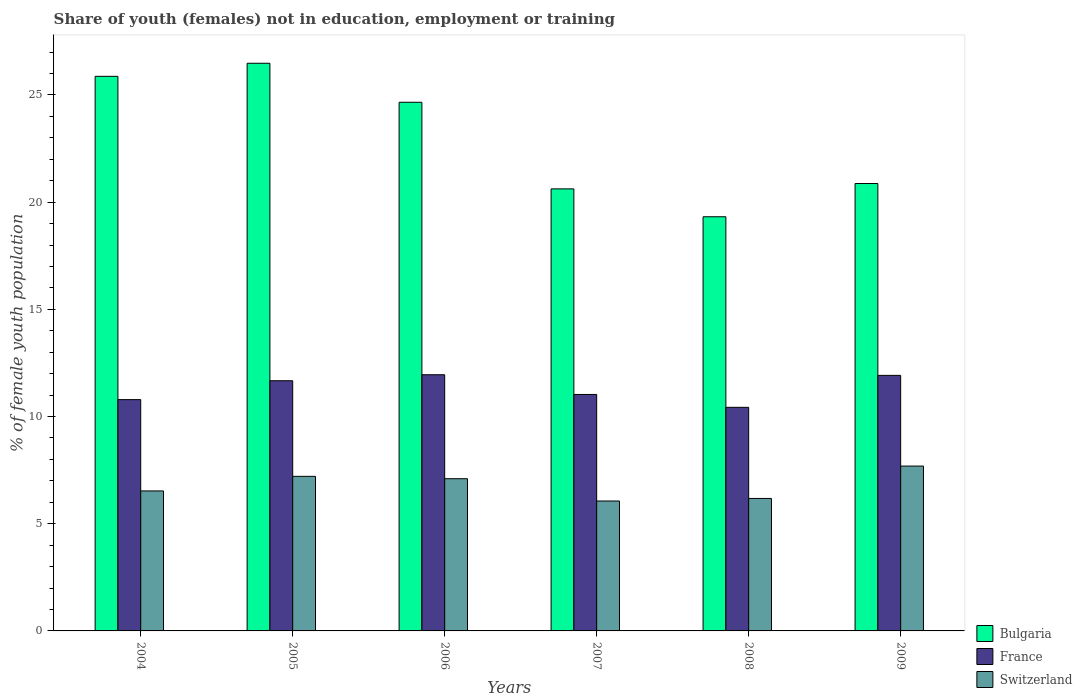How many groups of bars are there?
Make the answer very short. 6. Are the number of bars per tick equal to the number of legend labels?
Your answer should be very brief. Yes. Are the number of bars on each tick of the X-axis equal?
Provide a succinct answer. Yes. How many bars are there on the 3rd tick from the right?
Your answer should be very brief. 3. What is the percentage of unemployed female population in in Switzerland in 2006?
Provide a succinct answer. 7.1. Across all years, what is the maximum percentage of unemployed female population in in Switzerland?
Make the answer very short. 7.69. Across all years, what is the minimum percentage of unemployed female population in in Switzerland?
Provide a short and direct response. 6.06. What is the total percentage of unemployed female population in in Bulgaria in the graph?
Keep it short and to the point. 137.82. What is the difference between the percentage of unemployed female population in in Switzerland in 2006 and that in 2008?
Make the answer very short. 0.92. What is the difference between the percentage of unemployed female population in in France in 2005 and the percentage of unemployed female population in in Switzerland in 2009?
Provide a short and direct response. 3.98. What is the average percentage of unemployed female population in in Switzerland per year?
Provide a short and direct response. 6.79. In the year 2007, what is the difference between the percentage of unemployed female population in in France and percentage of unemployed female population in in Bulgaria?
Give a very brief answer. -9.59. What is the ratio of the percentage of unemployed female population in in Bulgaria in 2006 to that in 2008?
Make the answer very short. 1.28. Is the percentage of unemployed female population in in France in 2005 less than that in 2009?
Your answer should be very brief. Yes. What is the difference between the highest and the second highest percentage of unemployed female population in in Switzerland?
Ensure brevity in your answer.  0.48. What is the difference between the highest and the lowest percentage of unemployed female population in in France?
Your answer should be compact. 1.52. In how many years, is the percentage of unemployed female population in in Switzerland greater than the average percentage of unemployed female population in in Switzerland taken over all years?
Provide a succinct answer. 3. Is it the case that in every year, the sum of the percentage of unemployed female population in in France and percentage of unemployed female population in in Bulgaria is greater than the percentage of unemployed female population in in Switzerland?
Your answer should be very brief. Yes. Are the values on the major ticks of Y-axis written in scientific E-notation?
Keep it short and to the point. No. Does the graph contain any zero values?
Offer a terse response. No. How many legend labels are there?
Provide a short and direct response. 3. How are the legend labels stacked?
Provide a succinct answer. Vertical. What is the title of the graph?
Keep it short and to the point. Share of youth (females) not in education, employment or training. What is the label or title of the Y-axis?
Give a very brief answer. % of female youth population. What is the % of female youth population of Bulgaria in 2004?
Give a very brief answer. 25.87. What is the % of female youth population of France in 2004?
Keep it short and to the point. 10.79. What is the % of female youth population in Switzerland in 2004?
Make the answer very short. 6.53. What is the % of female youth population of Bulgaria in 2005?
Make the answer very short. 26.48. What is the % of female youth population in France in 2005?
Keep it short and to the point. 11.67. What is the % of female youth population in Switzerland in 2005?
Make the answer very short. 7.21. What is the % of female youth population of Bulgaria in 2006?
Provide a succinct answer. 24.66. What is the % of female youth population in France in 2006?
Keep it short and to the point. 11.95. What is the % of female youth population in Switzerland in 2006?
Your answer should be very brief. 7.1. What is the % of female youth population in Bulgaria in 2007?
Your answer should be very brief. 20.62. What is the % of female youth population of France in 2007?
Offer a very short reply. 11.03. What is the % of female youth population in Switzerland in 2007?
Provide a short and direct response. 6.06. What is the % of female youth population in Bulgaria in 2008?
Provide a short and direct response. 19.32. What is the % of female youth population of France in 2008?
Your response must be concise. 10.43. What is the % of female youth population of Switzerland in 2008?
Make the answer very short. 6.18. What is the % of female youth population in Bulgaria in 2009?
Offer a very short reply. 20.87. What is the % of female youth population of France in 2009?
Your response must be concise. 11.92. What is the % of female youth population in Switzerland in 2009?
Your answer should be very brief. 7.69. Across all years, what is the maximum % of female youth population in Bulgaria?
Your answer should be compact. 26.48. Across all years, what is the maximum % of female youth population of France?
Your response must be concise. 11.95. Across all years, what is the maximum % of female youth population of Switzerland?
Your answer should be compact. 7.69. Across all years, what is the minimum % of female youth population in Bulgaria?
Make the answer very short. 19.32. Across all years, what is the minimum % of female youth population in France?
Offer a very short reply. 10.43. Across all years, what is the minimum % of female youth population of Switzerland?
Your answer should be compact. 6.06. What is the total % of female youth population in Bulgaria in the graph?
Provide a succinct answer. 137.82. What is the total % of female youth population in France in the graph?
Offer a very short reply. 67.79. What is the total % of female youth population in Switzerland in the graph?
Provide a succinct answer. 40.77. What is the difference between the % of female youth population in Bulgaria in 2004 and that in 2005?
Offer a terse response. -0.61. What is the difference between the % of female youth population in France in 2004 and that in 2005?
Offer a very short reply. -0.88. What is the difference between the % of female youth population of Switzerland in 2004 and that in 2005?
Make the answer very short. -0.68. What is the difference between the % of female youth population of Bulgaria in 2004 and that in 2006?
Provide a succinct answer. 1.21. What is the difference between the % of female youth population in France in 2004 and that in 2006?
Provide a short and direct response. -1.16. What is the difference between the % of female youth population in Switzerland in 2004 and that in 2006?
Offer a terse response. -0.57. What is the difference between the % of female youth population in Bulgaria in 2004 and that in 2007?
Your answer should be compact. 5.25. What is the difference between the % of female youth population of France in 2004 and that in 2007?
Provide a succinct answer. -0.24. What is the difference between the % of female youth population of Switzerland in 2004 and that in 2007?
Keep it short and to the point. 0.47. What is the difference between the % of female youth population in Bulgaria in 2004 and that in 2008?
Offer a terse response. 6.55. What is the difference between the % of female youth population of France in 2004 and that in 2008?
Give a very brief answer. 0.36. What is the difference between the % of female youth population in Bulgaria in 2004 and that in 2009?
Your answer should be compact. 5. What is the difference between the % of female youth population of France in 2004 and that in 2009?
Keep it short and to the point. -1.13. What is the difference between the % of female youth population of Switzerland in 2004 and that in 2009?
Your response must be concise. -1.16. What is the difference between the % of female youth population of Bulgaria in 2005 and that in 2006?
Provide a succinct answer. 1.82. What is the difference between the % of female youth population in France in 2005 and that in 2006?
Offer a very short reply. -0.28. What is the difference between the % of female youth population in Switzerland in 2005 and that in 2006?
Offer a very short reply. 0.11. What is the difference between the % of female youth population in Bulgaria in 2005 and that in 2007?
Provide a short and direct response. 5.86. What is the difference between the % of female youth population of France in 2005 and that in 2007?
Ensure brevity in your answer.  0.64. What is the difference between the % of female youth population in Switzerland in 2005 and that in 2007?
Your answer should be compact. 1.15. What is the difference between the % of female youth population of Bulgaria in 2005 and that in 2008?
Your response must be concise. 7.16. What is the difference between the % of female youth population in France in 2005 and that in 2008?
Offer a terse response. 1.24. What is the difference between the % of female youth population in Switzerland in 2005 and that in 2008?
Keep it short and to the point. 1.03. What is the difference between the % of female youth population in Bulgaria in 2005 and that in 2009?
Your response must be concise. 5.61. What is the difference between the % of female youth population of Switzerland in 2005 and that in 2009?
Provide a short and direct response. -0.48. What is the difference between the % of female youth population in Bulgaria in 2006 and that in 2007?
Provide a succinct answer. 4.04. What is the difference between the % of female youth population in Switzerland in 2006 and that in 2007?
Keep it short and to the point. 1.04. What is the difference between the % of female youth population in Bulgaria in 2006 and that in 2008?
Offer a terse response. 5.34. What is the difference between the % of female youth population of France in 2006 and that in 2008?
Offer a very short reply. 1.52. What is the difference between the % of female youth population in Bulgaria in 2006 and that in 2009?
Your answer should be compact. 3.79. What is the difference between the % of female youth population in France in 2006 and that in 2009?
Provide a succinct answer. 0.03. What is the difference between the % of female youth population in Switzerland in 2006 and that in 2009?
Your answer should be very brief. -0.59. What is the difference between the % of female youth population of France in 2007 and that in 2008?
Offer a very short reply. 0.6. What is the difference between the % of female youth population in Switzerland in 2007 and that in 2008?
Make the answer very short. -0.12. What is the difference between the % of female youth population of Bulgaria in 2007 and that in 2009?
Give a very brief answer. -0.25. What is the difference between the % of female youth population in France in 2007 and that in 2009?
Provide a short and direct response. -0.89. What is the difference between the % of female youth population in Switzerland in 2007 and that in 2009?
Provide a succinct answer. -1.63. What is the difference between the % of female youth population in Bulgaria in 2008 and that in 2009?
Your response must be concise. -1.55. What is the difference between the % of female youth population in France in 2008 and that in 2009?
Make the answer very short. -1.49. What is the difference between the % of female youth population in Switzerland in 2008 and that in 2009?
Provide a succinct answer. -1.51. What is the difference between the % of female youth population of Bulgaria in 2004 and the % of female youth population of Switzerland in 2005?
Provide a succinct answer. 18.66. What is the difference between the % of female youth population of France in 2004 and the % of female youth population of Switzerland in 2005?
Give a very brief answer. 3.58. What is the difference between the % of female youth population of Bulgaria in 2004 and the % of female youth population of France in 2006?
Your answer should be very brief. 13.92. What is the difference between the % of female youth population of Bulgaria in 2004 and the % of female youth population of Switzerland in 2006?
Offer a terse response. 18.77. What is the difference between the % of female youth population of France in 2004 and the % of female youth population of Switzerland in 2006?
Give a very brief answer. 3.69. What is the difference between the % of female youth population in Bulgaria in 2004 and the % of female youth population in France in 2007?
Keep it short and to the point. 14.84. What is the difference between the % of female youth population in Bulgaria in 2004 and the % of female youth population in Switzerland in 2007?
Make the answer very short. 19.81. What is the difference between the % of female youth population of France in 2004 and the % of female youth population of Switzerland in 2007?
Your answer should be very brief. 4.73. What is the difference between the % of female youth population of Bulgaria in 2004 and the % of female youth population of France in 2008?
Ensure brevity in your answer.  15.44. What is the difference between the % of female youth population of Bulgaria in 2004 and the % of female youth population of Switzerland in 2008?
Provide a short and direct response. 19.69. What is the difference between the % of female youth population in France in 2004 and the % of female youth population in Switzerland in 2008?
Make the answer very short. 4.61. What is the difference between the % of female youth population in Bulgaria in 2004 and the % of female youth population in France in 2009?
Your answer should be compact. 13.95. What is the difference between the % of female youth population of Bulgaria in 2004 and the % of female youth population of Switzerland in 2009?
Give a very brief answer. 18.18. What is the difference between the % of female youth population of France in 2004 and the % of female youth population of Switzerland in 2009?
Ensure brevity in your answer.  3.1. What is the difference between the % of female youth population in Bulgaria in 2005 and the % of female youth population in France in 2006?
Make the answer very short. 14.53. What is the difference between the % of female youth population in Bulgaria in 2005 and the % of female youth population in Switzerland in 2006?
Keep it short and to the point. 19.38. What is the difference between the % of female youth population in France in 2005 and the % of female youth population in Switzerland in 2006?
Your response must be concise. 4.57. What is the difference between the % of female youth population of Bulgaria in 2005 and the % of female youth population of France in 2007?
Offer a very short reply. 15.45. What is the difference between the % of female youth population in Bulgaria in 2005 and the % of female youth population in Switzerland in 2007?
Provide a short and direct response. 20.42. What is the difference between the % of female youth population of France in 2005 and the % of female youth population of Switzerland in 2007?
Offer a terse response. 5.61. What is the difference between the % of female youth population in Bulgaria in 2005 and the % of female youth population in France in 2008?
Provide a short and direct response. 16.05. What is the difference between the % of female youth population in Bulgaria in 2005 and the % of female youth population in Switzerland in 2008?
Make the answer very short. 20.3. What is the difference between the % of female youth population in France in 2005 and the % of female youth population in Switzerland in 2008?
Your answer should be very brief. 5.49. What is the difference between the % of female youth population of Bulgaria in 2005 and the % of female youth population of France in 2009?
Ensure brevity in your answer.  14.56. What is the difference between the % of female youth population of Bulgaria in 2005 and the % of female youth population of Switzerland in 2009?
Provide a succinct answer. 18.79. What is the difference between the % of female youth population of France in 2005 and the % of female youth population of Switzerland in 2009?
Make the answer very short. 3.98. What is the difference between the % of female youth population of Bulgaria in 2006 and the % of female youth population of France in 2007?
Provide a short and direct response. 13.63. What is the difference between the % of female youth population in France in 2006 and the % of female youth population in Switzerland in 2007?
Your answer should be very brief. 5.89. What is the difference between the % of female youth population in Bulgaria in 2006 and the % of female youth population in France in 2008?
Provide a short and direct response. 14.23. What is the difference between the % of female youth population in Bulgaria in 2006 and the % of female youth population in Switzerland in 2008?
Make the answer very short. 18.48. What is the difference between the % of female youth population of France in 2006 and the % of female youth population of Switzerland in 2008?
Keep it short and to the point. 5.77. What is the difference between the % of female youth population of Bulgaria in 2006 and the % of female youth population of France in 2009?
Offer a very short reply. 12.74. What is the difference between the % of female youth population in Bulgaria in 2006 and the % of female youth population in Switzerland in 2009?
Your answer should be very brief. 16.97. What is the difference between the % of female youth population in France in 2006 and the % of female youth population in Switzerland in 2009?
Give a very brief answer. 4.26. What is the difference between the % of female youth population of Bulgaria in 2007 and the % of female youth population of France in 2008?
Your answer should be very brief. 10.19. What is the difference between the % of female youth population in Bulgaria in 2007 and the % of female youth population in Switzerland in 2008?
Your answer should be compact. 14.44. What is the difference between the % of female youth population in France in 2007 and the % of female youth population in Switzerland in 2008?
Give a very brief answer. 4.85. What is the difference between the % of female youth population in Bulgaria in 2007 and the % of female youth population in Switzerland in 2009?
Provide a succinct answer. 12.93. What is the difference between the % of female youth population in France in 2007 and the % of female youth population in Switzerland in 2009?
Offer a very short reply. 3.34. What is the difference between the % of female youth population of Bulgaria in 2008 and the % of female youth population of Switzerland in 2009?
Your answer should be compact. 11.63. What is the difference between the % of female youth population of France in 2008 and the % of female youth population of Switzerland in 2009?
Offer a very short reply. 2.74. What is the average % of female youth population in Bulgaria per year?
Provide a short and direct response. 22.97. What is the average % of female youth population in France per year?
Provide a succinct answer. 11.3. What is the average % of female youth population in Switzerland per year?
Give a very brief answer. 6.79. In the year 2004, what is the difference between the % of female youth population in Bulgaria and % of female youth population in France?
Keep it short and to the point. 15.08. In the year 2004, what is the difference between the % of female youth population in Bulgaria and % of female youth population in Switzerland?
Your response must be concise. 19.34. In the year 2004, what is the difference between the % of female youth population of France and % of female youth population of Switzerland?
Your answer should be very brief. 4.26. In the year 2005, what is the difference between the % of female youth population of Bulgaria and % of female youth population of France?
Make the answer very short. 14.81. In the year 2005, what is the difference between the % of female youth population of Bulgaria and % of female youth population of Switzerland?
Make the answer very short. 19.27. In the year 2005, what is the difference between the % of female youth population of France and % of female youth population of Switzerland?
Offer a very short reply. 4.46. In the year 2006, what is the difference between the % of female youth population in Bulgaria and % of female youth population in France?
Provide a succinct answer. 12.71. In the year 2006, what is the difference between the % of female youth population of Bulgaria and % of female youth population of Switzerland?
Ensure brevity in your answer.  17.56. In the year 2006, what is the difference between the % of female youth population of France and % of female youth population of Switzerland?
Keep it short and to the point. 4.85. In the year 2007, what is the difference between the % of female youth population of Bulgaria and % of female youth population of France?
Ensure brevity in your answer.  9.59. In the year 2007, what is the difference between the % of female youth population in Bulgaria and % of female youth population in Switzerland?
Offer a terse response. 14.56. In the year 2007, what is the difference between the % of female youth population in France and % of female youth population in Switzerland?
Offer a terse response. 4.97. In the year 2008, what is the difference between the % of female youth population in Bulgaria and % of female youth population in France?
Provide a short and direct response. 8.89. In the year 2008, what is the difference between the % of female youth population in Bulgaria and % of female youth population in Switzerland?
Give a very brief answer. 13.14. In the year 2008, what is the difference between the % of female youth population in France and % of female youth population in Switzerland?
Provide a succinct answer. 4.25. In the year 2009, what is the difference between the % of female youth population of Bulgaria and % of female youth population of France?
Your answer should be compact. 8.95. In the year 2009, what is the difference between the % of female youth population in Bulgaria and % of female youth population in Switzerland?
Keep it short and to the point. 13.18. In the year 2009, what is the difference between the % of female youth population in France and % of female youth population in Switzerland?
Your answer should be very brief. 4.23. What is the ratio of the % of female youth population of France in 2004 to that in 2005?
Your answer should be very brief. 0.92. What is the ratio of the % of female youth population in Switzerland in 2004 to that in 2005?
Your answer should be very brief. 0.91. What is the ratio of the % of female youth population in Bulgaria in 2004 to that in 2006?
Offer a terse response. 1.05. What is the ratio of the % of female youth population of France in 2004 to that in 2006?
Your response must be concise. 0.9. What is the ratio of the % of female youth population in Switzerland in 2004 to that in 2006?
Provide a succinct answer. 0.92. What is the ratio of the % of female youth population in Bulgaria in 2004 to that in 2007?
Offer a terse response. 1.25. What is the ratio of the % of female youth population in France in 2004 to that in 2007?
Ensure brevity in your answer.  0.98. What is the ratio of the % of female youth population in Switzerland in 2004 to that in 2007?
Your answer should be compact. 1.08. What is the ratio of the % of female youth population of Bulgaria in 2004 to that in 2008?
Your answer should be compact. 1.34. What is the ratio of the % of female youth population of France in 2004 to that in 2008?
Give a very brief answer. 1.03. What is the ratio of the % of female youth population of Switzerland in 2004 to that in 2008?
Provide a short and direct response. 1.06. What is the ratio of the % of female youth population of Bulgaria in 2004 to that in 2009?
Your answer should be very brief. 1.24. What is the ratio of the % of female youth population in France in 2004 to that in 2009?
Your answer should be very brief. 0.91. What is the ratio of the % of female youth population of Switzerland in 2004 to that in 2009?
Provide a succinct answer. 0.85. What is the ratio of the % of female youth population of Bulgaria in 2005 to that in 2006?
Ensure brevity in your answer.  1.07. What is the ratio of the % of female youth population in France in 2005 to that in 2006?
Offer a terse response. 0.98. What is the ratio of the % of female youth population of Switzerland in 2005 to that in 2006?
Offer a very short reply. 1.02. What is the ratio of the % of female youth population in Bulgaria in 2005 to that in 2007?
Your response must be concise. 1.28. What is the ratio of the % of female youth population in France in 2005 to that in 2007?
Keep it short and to the point. 1.06. What is the ratio of the % of female youth population in Switzerland in 2005 to that in 2007?
Your answer should be compact. 1.19. What is the ratio of the % of female youth population in Bulgaria in 2005 to that in 2008?
Make the answer very short. 1.37. What is the ratio of the % of female youth population in France in 2005 to that in 2008?
Ensure brevity in your answer.  1.12. What is the ratio of the % of female youth population of Switzerland in 2005 to that in 2008?
Offer a very short reply. 1.17. What is the ratio of the % of female youth population in Bulgaria in 2005 to that in 2009?
Your answer should be very brief. 1.27. What is the ratio of the % of female youth population in France in 2005 to that in 2009?
Ensure brevity in your answer.  0.98. What is the ratio of the % of female youth population of Switzerland in 2005 to that in 2009?
Ensure brevity in your answer.  0.94. What is the ratio of the % of female youth population of Bulgaria in 2006 to that in 2007?
Make the answer very short. 1.2. What is the ratio of the % of female youth population of France in 2006 to that in 2007?
Give a very brief answer. 1.08. What is the ratio of the % of female youth population in Switzerland in 2006 to that in 2007?
Make the answer very short. 1.17. What is the ratio of the % of female youth population in Bulgaria in 2006 to that in 2008?
Make the answer very short. 1.28. What is the ratio of the % of female youth population in France in 2006 to that in 2008?
Offer a terse response. 1.15. What is the ratio of the % of female youth population of Switzerland in 2006 to that in 2008?
Provide a succinct answer. 1.15. What is the ratio of the % of female youth population of Bulgaria in 2006 to that in 2009?
Offer a very short reply. 1.18. What is the ratio of the % of female youth population of Switzerland in 2006 to that in 2009?
Offer a terse response. 0.92. What is the ratio of the % of female youth population of Bulgaria in 2007 to that in 2008?
Offer a terse response. 1.07. What is the ratio of the % of female youth population in France in 2007 to that in 2008?
Make the answer very short. 1.06. What is the ratio of the % of female youth population of Switzerland in 2007 to that in 2008?
Keep it short and to the point. 0.98. What is the ratio of the % of female youth population in Bulgaria in 2007 to that in 2009?
Provide a succinct answer. 0.99. What is the ratio of the % of female youth population of France in 2007 to that in 2009?
Provide a succinct answer. 0.93. What is the ratio of the % of female youth population of Switzerland in 2007 to that in 2009?
Your response must be concise. 0.79. What is the ratio of the % of female youth population in Bulgaria in 2008 to that in 2009?
Offer a terse response. 0.93. What is the ratio of the % of female youth population in France in 2008 to that in 2009?
Your answer should be very brief. 0.88. What is the ratio of the % of female youth population of Switzerland in 2008 to that in 2009?
Your answer should be very brief. 0.8. What is the difference between the highest and the second highest % of female youth population in Bulgaria?
Ensure brevity in your answer.  0.61. What is the difference between the highest and the second highest % of female youth population of Switzerland?
Make the answer very short. 0.48. What is the difference between the highest and the lowest % of female youth population of Bulgaria?
Offer a very short reply. 7.16. What is the difference between the highest and the lowest % of female youth population in France?
Make the answer very short. 1.52. What is the difference between the highest and the lowest % of female youth population in Switzerland?
Offer a very short reply. 1.63. 